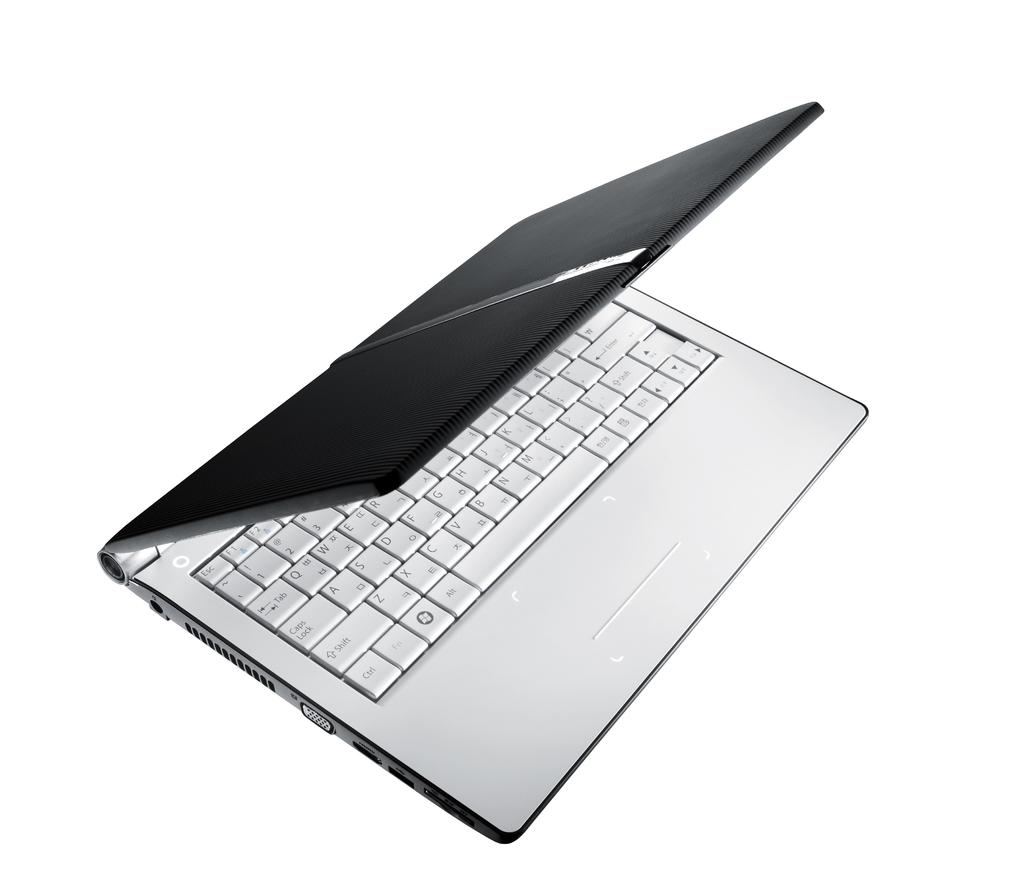<image>
Share a concise interpretation of the image provided. the word alt is on the white keyboard 